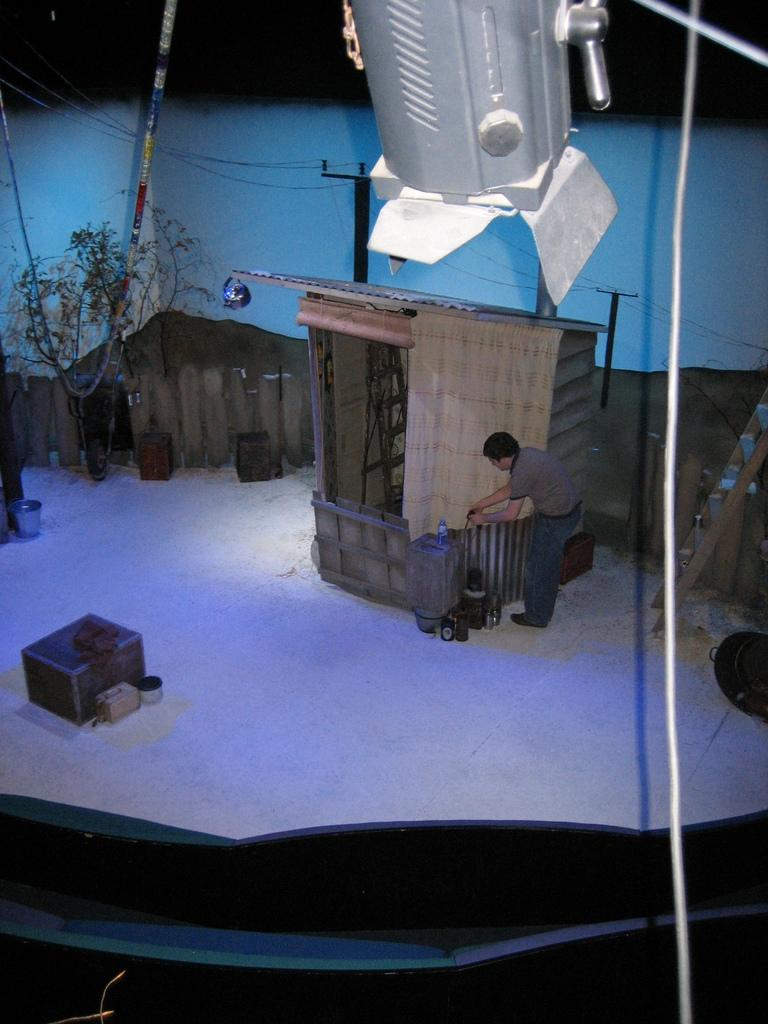Who is present in the image? There is a man in the image. What type of structure can be seen in the image? There is a small house in the image. What natural element is present in the image? There is a tree in the image. What objects are made of wood in the image? There are wooden boxes in the image. Where is the ladder located in the image? The ladder is on the right side of the image. What is the source of light in the image? There is visible light in the image. What type of park can be seen in the image? There is no park present in the image. How comfortable is the man sitting on the ladder in the image? The image does not provide information about the man's comfort, as it only shows his presence and the ladder's location. 